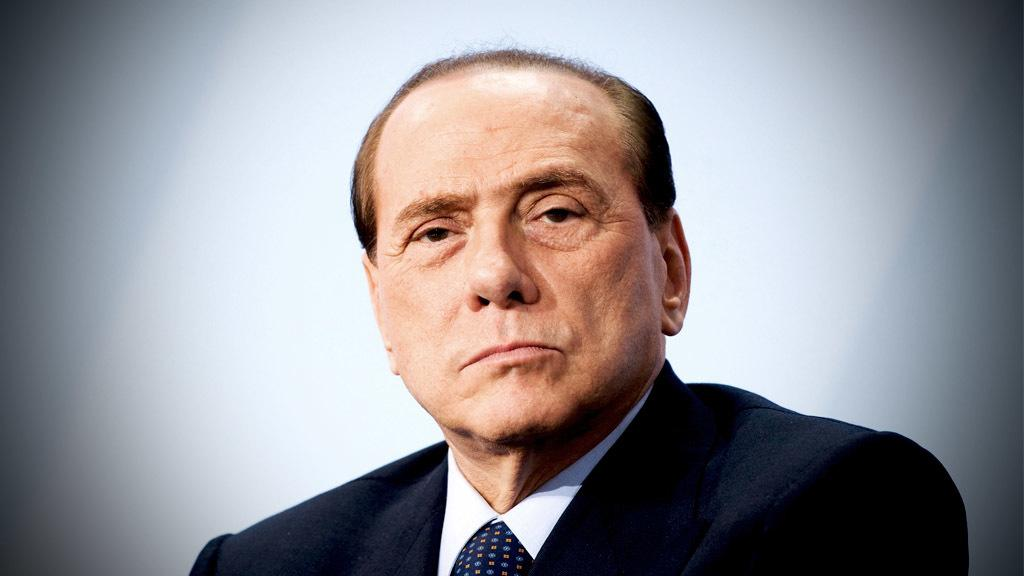Who is present in the image? There is a man in the image. What is the man wearing in the image? The man is wearing a blazer. What is the color of the background in the image? The background in the image is white. How many pets are visible in the image? There are no pets present in the image. What type of honey is being used to sweeten the man's tea in the image? There is no tea or honey present in the image. 